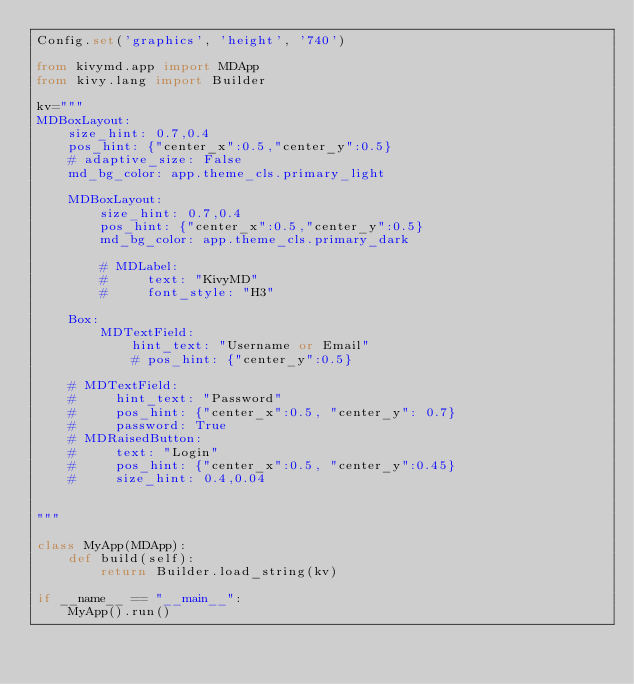<code> <loc_0><loc_0><loc_500><loc_500><_Python_>Config.set('graphics', 'height', '740')

from kivymd.app import MDApp
from kivy.lang import Builder

kv="""
MDBoxLayout:
    size_hint: 0.7,0.4
    pos_hint: {"center_x":0.5,"center_y":0.5}
    # adaptive_size: False
    md_bg_color: app.theme_cls.primary_light
    
    MDBoxLayout:
        size_hint: 0.7,0.4 
        pos_hint: {"center_x":0.5,"center_y":0.5}
        md_bg_color: app.theme_cls.primary_dark
        
        # MDLabel:
        #     text: "KivyMD"            
        #     font_style: "H3"

    Box:
        MDTextField:
            hint_text: "Username or Email"
            # pos_hint: {"center_y":0.5}
            
    # MDTextField:
    #     hint_text: "Password"
    #     pos_hint: {"center_x":0.5, "center_y": 0.7}
    #     password: True
    # MDRaisedButton:
    #     text: "Login"
    #     pos_hint: {"center_x":0.5, "center_y":0.45}
    #     size_hint: 0.4,0.04
        

"""

class MyApp(MDApp):
    def build(self):
        return Builder.load_string(kv)

if __name__ == "__main__":
    MyApp().run()</code> 